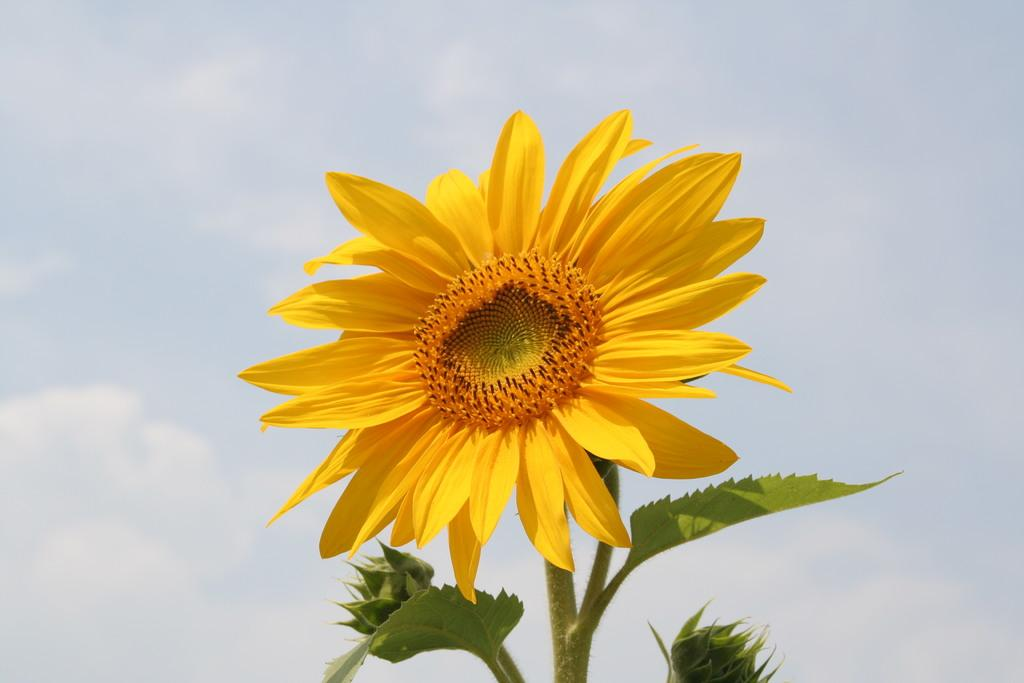What type of plant is in the image? There is a sunflower plant in the image. What is the main feature of the sunflower plant? The sunflower plant has a sunflower. What can be seen in the sky in the background of the image? There are clouds in the sky in the background of the image. How many horses are grazing in the field next to the sunflower plant in the image? There are no horses present in the image; it only features a sunflower plant and clouds in the sky. 